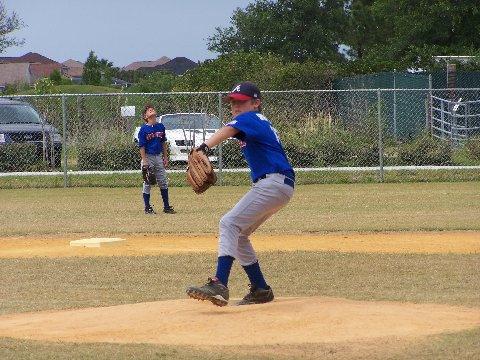What is the player in the outfield looking at?
Answer briefly. Sky. How many tennis rackets do you see?
Quick response, please. 0. Are the baseball players adults?
Concise answer only. No. Which hand has a mitt?
Write a very short answer. Left. 